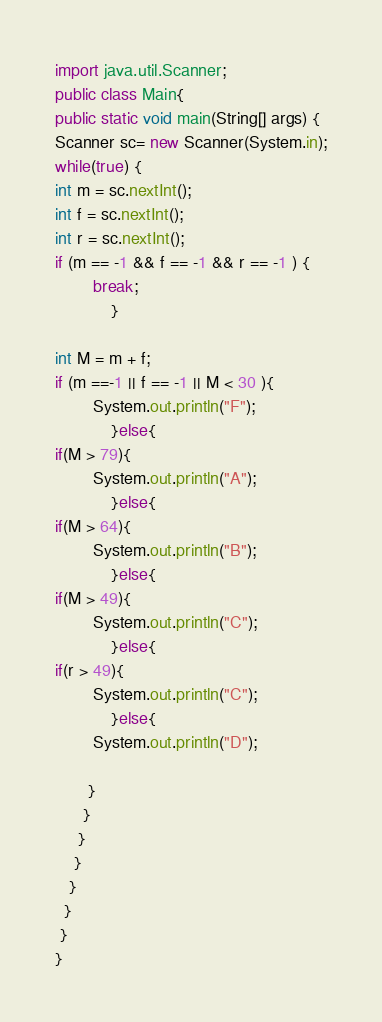Convert code to text. <code><loc_0><loc_0><loc_500><loc_500><_Java_>import java.util.Scanner;
public class Main{
public static void main(String[] args) {
Scanner sc= new Scanner(System.in);
while(true) {
int m = sc.nextInt();
int f = sc.nextInt();
int r = sc.nextInt();
if (m == -1 && f == -1 && r == -1 ) {
		break;
			}

int M = m + f;
if (m ==-1 || f == -1 || M < 30 ){
		System.out.println("F");
			}else{
if(M > 79){
		System.out.println("A");
			}else{
if(M > 64){
		System.out.println("B");
			}else{
if(M > 49){
		System.out.println("C");
			}else{
if(r > 49){
		System.out.println("C");
			}else{
		System.out.println("D");
        
       }       
      }
     }
    } 
   }
  }
 }
}</code> 